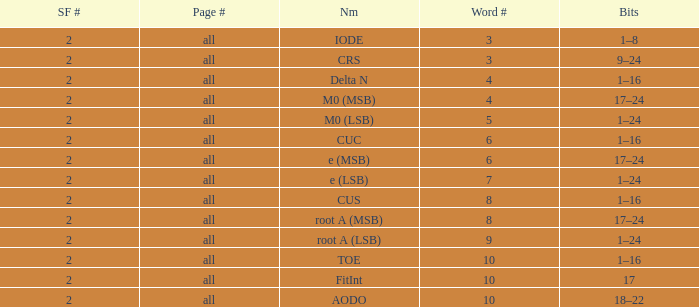What is the average word count with crs and subframes lesser than 2? None. 